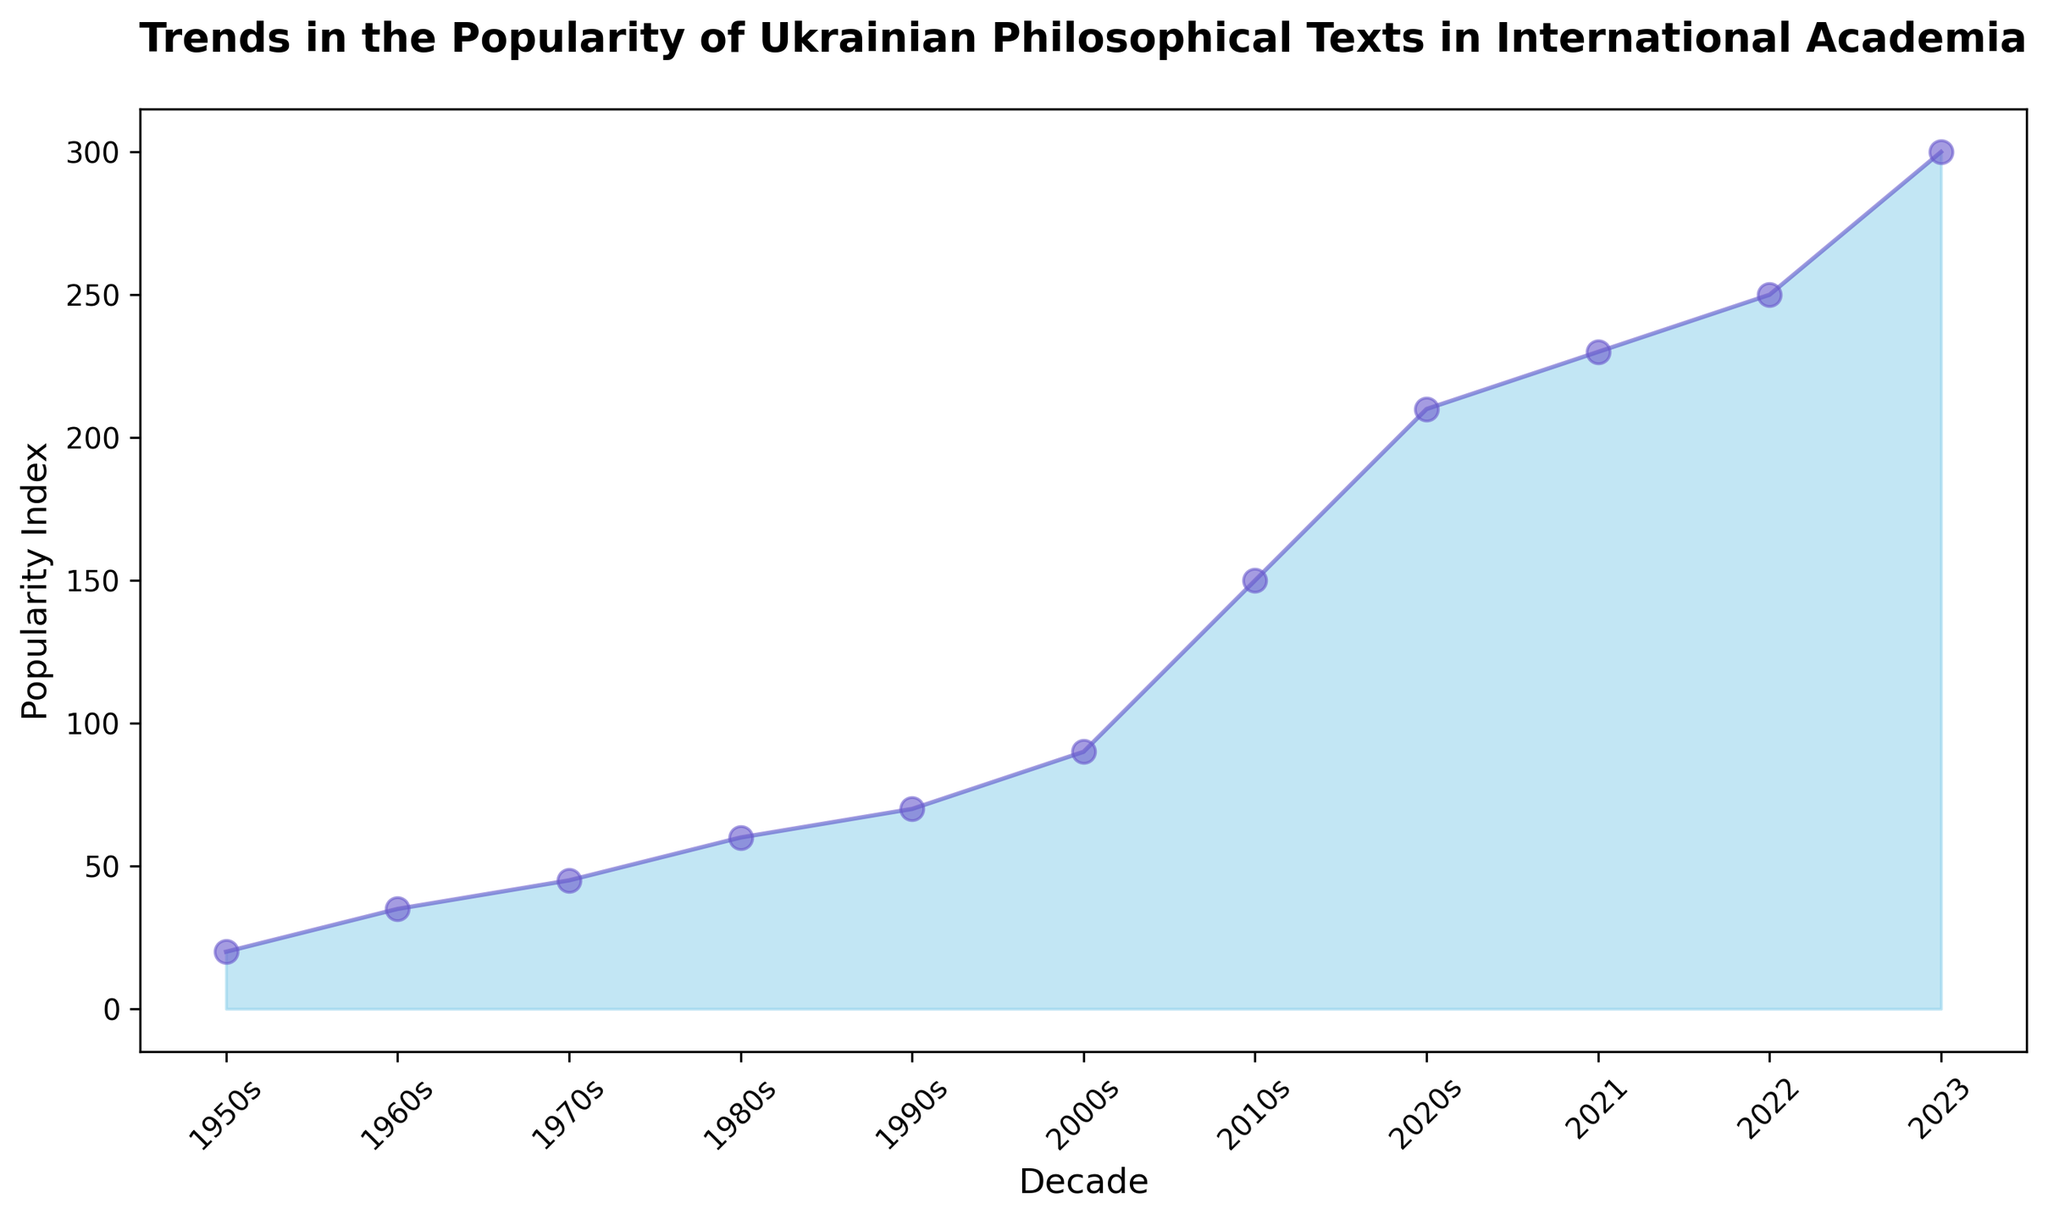What's the increase in the popularity index from the 1950s to the 1980s? To determine the increase, we subtract the popularity index of the 1950s from the popularity index of the 1980s. That is 60 (1980s) - 20 (1950s) = 40.
Answer: 40 Which decade had the highest popularity index? By observing the chart, the highest point on the plot touches the 2020s, indicating the peak popularity index of 210.
Answer: 2020s Between which two consecutive decades was the greatest increase in popularity index observed? We need to check the differences between consecutive decades and identify the maximum. The differences are: 1960s-1950s (15), 1970s-1960s (10), 1980s-1970s (15), 1990s-1980s (10), 2000s-1990s (20), 2010s-2000s (60), 2020s-2010s (60). The greatest increase is 60, between 2010s and 2020s.
Answer: 2010s to 2020s By how much did the popularity index increase from the 2020s to 2023? To calculate the increase, subtract the index in the 2020s from the index in 2023. That is 300 (2023) - 210 (2020s) = 90.
Answer: 90 Compare the popularity index in the 1990s and 2000s. Which one is higher? By observing the plot, it is evident that the popularity index in the 2000s is higher (90) compared to the 1990s (70).
Answer: 2000s What is the total increase in popularity index from the 1950s to the 2023? To find the total increase, subtract the index of the 1950s from the index of 2023. That is 300 (2023) - 20 (1950s) = 280.
Answer: 280 How does the trend in popularity change visually from the 2010s onwards? The plot shows a steeper incline in the area chart from the 2010s onwards, with the popularity index rapidly increasing from 150 in the 2010s to 300 in 2023.
Answer: Steeper incline Did the popularity index double between any two decades? If yes, which ones? By checking the plot data points, the index doubles from 45 (1970s) to 90 (2000s) and from 150 (2010s) to 300 (2023).
Answer: 1970s to 2000s, 2010s to 2023 Does the area under the curve appear to be increasing or decreasing over time? The area under the curve is gradually increasing over time, as visualized by the consistently rising plot line and expanding shaded region.
Answer: Increasing What's the average popularity index from the 1950s to the 2023? Sum all the popularity indices and divide by the number of data points: (20 + 35 + 45 + 60 + 70 + 90 + 150 + 210 + 230 + 250 + 300)/11 = 1460/11 ≈ 132.73.
Answer: 132.73 